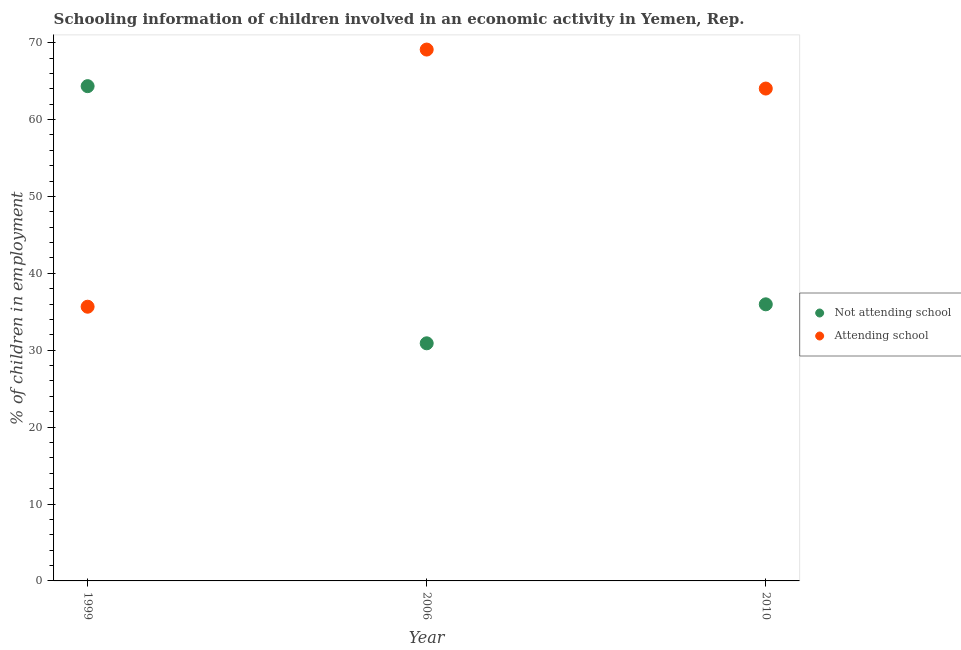How many different coloured dotlines are there?
Keep it short and to the point. 2. Is the number of dotlines equal to the number of legend labels?
Your answer should be compact. Yes. What is the percentage of employed children who are not attending school in 2006?
Your answer should be very brief. 30.9. Across all years, what is the maximum percentage of employed children who are attending school?
Offer a terse response. 69.1. Across all years, what is the minimum percentage of employed children who are attending school?
Ensure brevity in your answer.  35.66. What is the total percentage of employed children who are not attending school in the graph?
Your answer should be compact. 131.21. What is the difference between the percentage of employed children who are not attending school in 2006 and that in 2010?
Give a very brief answer. -5.07. What is the difference between the percentage of employed children who are not attending school in 2010 and the percentage of employed children who are attending school in 2006?
Give a very brief answer. -33.13. What is the average percentage of employed children who are attending school per year?
Your response must be concise. 56.26. In the year 1999, what is the difference between the percentage of employed children who are attending school and percentage of employed children who are not attending school?
Make the answer very short. -28.68. In how many years, is the percentage of employed children who are attending school greater than 30 %?
Ensure brevity in your answer.  3. What is the ratio of the percentage of employed children who are attending school in 1999 to that in 2010?
Provide a succinct answer. 0.56. Is the difference between the percentage of employed children who are attending school in 1999 and 2006 greater than the difference between the percentage of employed children who are not attending school in 1999 and 2006?
Offer a terse response. No. What is the difference between the highest and the second highest percentage of employed children who are not attending school?
Your answer should be compact. 28.37. What is the difference between the highest and the lowest percentage of employed children who are not attending school?
Your response must be concise. 33.44. In how many years, is the percentage of employed children who are not attending school greater than the average percentage of employed children who are not attending school taken over all years?
Offer a terse response. 1. Is the sum of the percentage of employed children who are attending school in 1999 and 2006 greater than the maximum percentage of employed children who are not attending school across all years?
Offer a very short reply. Yes. How many dotlines are there?
Make the answer very short. 2. How many years are there in the graph?
Keep it short and to the point. 3. Does the graph contain grids?
Your answer should be compact. No. How many legend labels are there?
Make the answer very short. 2. What is the title of the graph?
Offer a very short reply. Schooling information of children involved in an economic activity in Yemen, Rep. Does "Domestic liabilities" appear as one of the legend labels in the graph?
Your answer should be compact. No. What is the label or title of the Y-axis?
Provide a succinct answer. % of children in employment. What is the % of children in employment of Not attending school in 1999?
Make the answer very short. 64.34. What is the % of children in employment in Attending school in 1999?
Give a very brief answer. 35.66. What is the % of children in employment in Not attending school in 2006?
Your answer should be very brief. 30.9. What is the % of children in employment in Attending school in 2006?
Provide a short and direct response. 69.1. What is the % of children in employment of Not attending school in 2010?
Your answer should be compact. 35.97. What is the % of children in employment of Attending school in 2010?
Offer a terse response. 64.03. Across all years, what is the maximum % of children in employment in Not attending school?
Provide a succinct answer. 64.34. Across all years, what is the maximum % of children in employment of Attending school?
Your answer should be compact. 69.1. Across all years, what is the minimum % of children in employment in Not attending school?
Provide a short and direct response. 30.9. Across all years, what is the minimum % of children in employment of Attending school?
Provide a short and direct response. 35.66. What is the total % of children in employment in Not attending school in the graph?
Ensure brevity in your answer.  131.21. What is the total % of children in employment in Attending school in the graph?
Offer a terse response. 168.79. What is the difference between the % of children in employment of Not attending school in 1999 and that in 2006?
Offer a terse response. 33.44. What is the difference between the % of children in employment of Attending school in 1999 and that in 2006?
Keep it short and to the point. -33.44. What is the difference between the % of children in employment in Not attending school in 1999 and that in 2010?
Ensure brevity in your answer.  28.37. What is the difference between the % of children in employment of Attending school in 1999 and that in 2010?
Make the answer very short. -28.37. What is the difference between the % of children in employment of Not attending school in 2006 and that in 2010?
Give a very brief answer. -5.07. What is the difference between the % of children in employment of Attending school in 2006 and that in 2010?
Ensure brevity in your answer.  5.07. What is the difference between the % of children in employment in Not attending school in 1999 and the % of children in employment in Attending school in 2006?
Your response must be concise. -4.76. What is the difference between the % of children in employment in Not attending school in 1999 and the % of children in employment in Attending school in 2010?
Offer a very short reply. 0.31. What is the difference between the % of children in employment in Not attending school in 2006 and the % of children in employment in Attending school in 2010?
Your answer should be very brief. -33.13. What is the average % of children in employment in Not attending school per year?
Give a very brief answer. 43.74. What is the average % of children in employment of Attending school per year?
Give a very brief answer. 56.26. In the year 1999, what is the difference between the % of children in employment in Not attending school and % of children in employment in Attending school?
Your answer should be very brief. 28.68. In the year 2006, what is the difference between the % of children in employment in Not attending school and % of children in employment in Attending school?
Provide a succinct answer. -38.2. In the year 2010, what is the difference between the % of children in employment in Not attending school and % of children in employment in Attending school?
Provide a short and direct response. -28.06. What is the ratio of the % of children in employment in Not attending school in 1999 to that in 2006?
Ensure brevity in your answer.  2.08. What is the ratio of the % of children in employment of Attending school in 1999 to that in 2006?
Your response must be concise. 0.52. What is the ratio of the % of children in employment of Not attending school in 1999 to that in 2010?
Make the answer very short. 1.79. What is the ratio of the % of children in employment in Attending school in 1999 to that in 2010?
Offer a very short reply. 0.56. What is the ratio of the % of children in employment of Not attending school in 2006 to that in 2010?
Provide a short and direct response. 0.86. What is the ratio of the % of children in employment of Attending school in 2006 to that in 2010?
Your answer should be compact. 1.08. What is the difference between the highest and the second highest % of children in employment of Not attending school?
Keep it short and to the point. 28.37. What is the difference between the highest and the second highest % of children in employment of Attending school?
Ensure brevity in your answer.  5.07. What is the difference between the highest and the lowest % of children in employment in Not attending school?
Offer a very short reply. 33.44. What is the difference between the highest and the lowest % of children in employment of Attending school?
Ensure brevity in your answer.  33.44. 